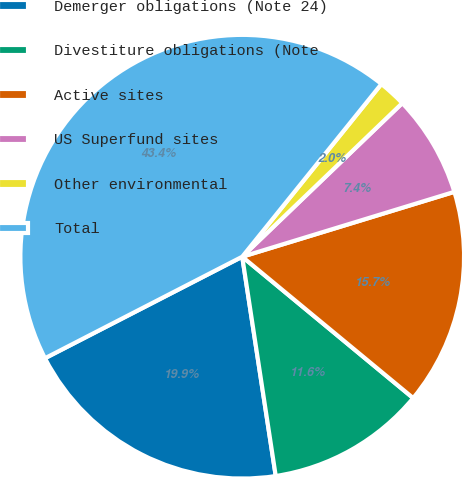Convert chart. <chart><loc_0><loc_0><loc_500><loc_500><pie_chart><fcel>Demerger obligations (Note 24)<fcel>Divestiture obligations (Note<fcel>Active sites<fcel>US Superfund sites<fcel>Other environmental<fcel>Total<nl><fcel>19.85%<fcel>11.59%<fcel>15.72%<fcel>7.45%<fcel>2.03%<fcel>43.36%<nl></chart> 